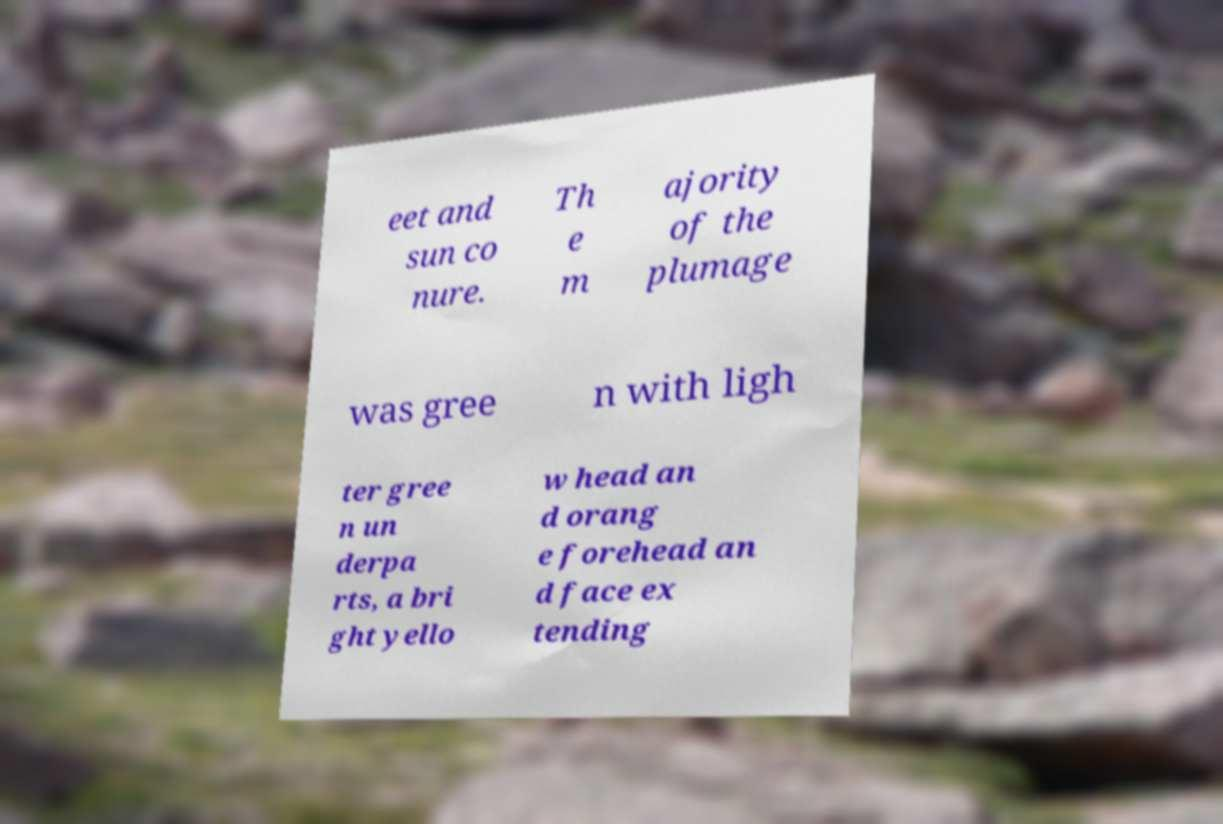Can you read and provide the text displayed in the image?This photo seems to have some interesting text. Can you extract and type it out for me? eet and sun co nure. Th e m ajority of the plumage was gree n with ligh ter gree n un derpa rts, a bri ght yello w head an d orang e forehead an d face ex tending 